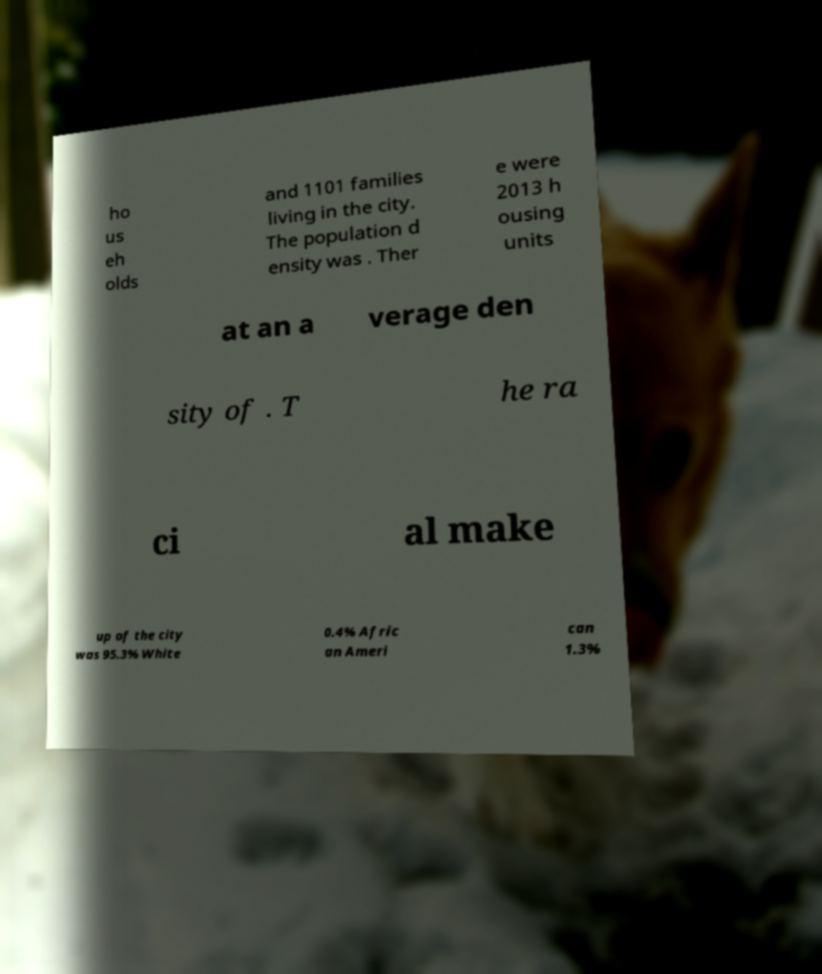What messages or text are displayed in this image? I need them in a readable, typed format. ho us eh olds and 1101 families living in the city. The population d ensity was . Ther e were 2013 h ousing units at an a verage den sity of . T he ra ci al make up of the city was 95.3% White 0.4% Afric an Ameri can 1.3% 